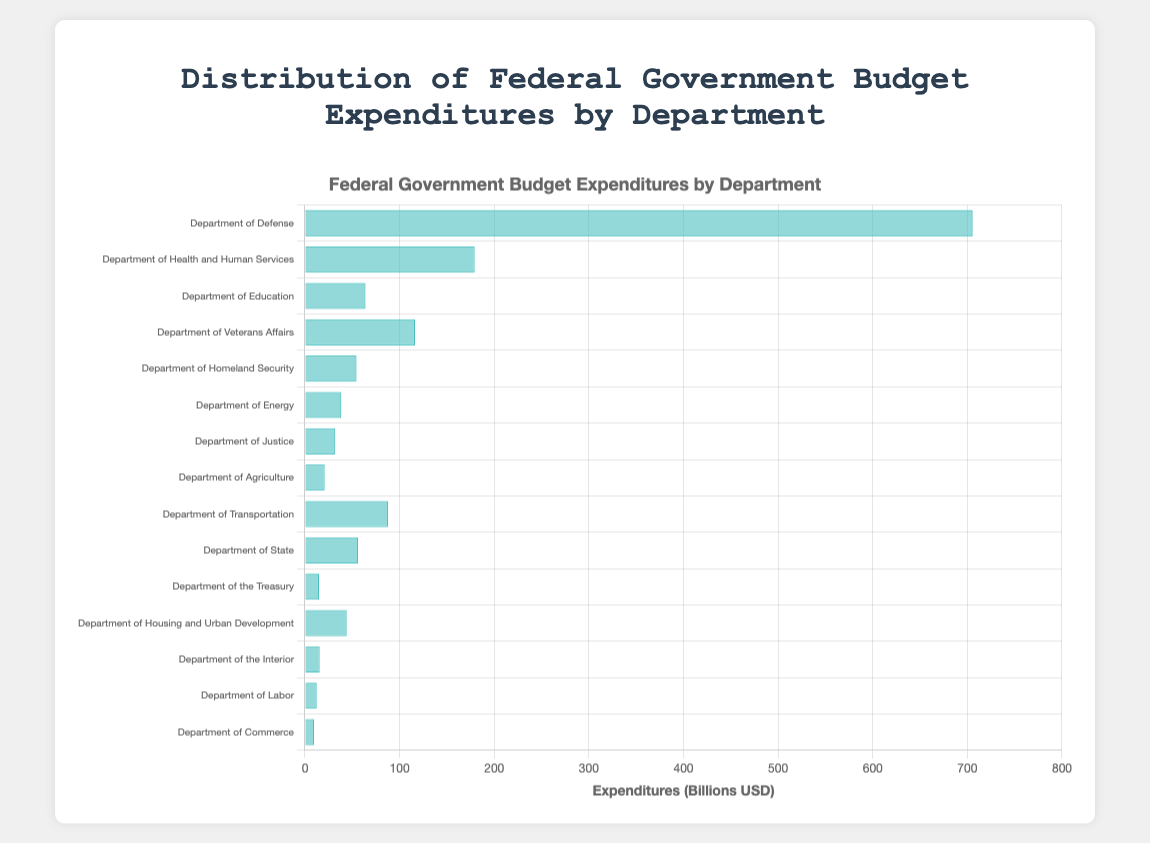Which department has the highest expenditures? The bar corresponding to the Department of Defense extends the farthest to the right, indicating it has the highest expenditures.
Answer: Department of Defense Which department has the lowest expenditures? The bar corresponding to the Department of Commerce is the shortest, indicating it has the lowest expenditures.
Answer: Department of Commerce Which department spends more, the Department of Transportation or the Department of Education? The bar for the Department of Transportation is longer than the bar for the Department of Education.
Answer: Department of Transportation Is the expenditure of the Department of State greater than that of the Department of Homeland Security? The bar for the Department of State is slightly longer than that of the Department of Homeland Security.
Answer: Yes What is the total expenditure of the Department of Energy and the Department of Commerce? Adding the expenditures of the Department of Energy (38.4) and the Department of Commerce (9.6) results in a total of 48.0.
Answer: 48.0 billion USD What is the average expenditure of the departments listed? The sum of all expenditures is 1415 billion USD, and there are 15 departments, so the average expenditure is 1415 / 15 = 94.3 billion USD.
Answer: 94.3 billion USD What is the difference in expenditure between the Department of Defense and the Department of Education? Subtracting the expenditure of the Department of Education (64.0) from that of the Department of Defense (705.4) results in a difference of 641.4.
Answer: 641.4 billion USD Which department's expenditure bar is the second longest? The second longest bar after the Department of Defense corresponds to the Department of Health and Human Services.
Answer: Department of Health and Human Services Are there more departments that spend above or below 50 billion USD? Counting the bars longer than 50 billion USD and those shorter, 7 bars are above and 8 are below.
Answer: Below 50 billion USD 